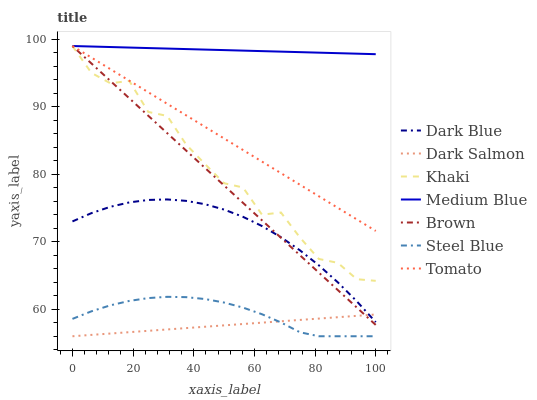Does Dark Salmon have the minimum area under the curve?
Answer yes or no. Yes. Does Medium Blue have the maximum area under the curve?
Answer yes or no. Yes. Does Brown have the minimum area under the curve?
Answer yes or no. No. Does Brown have the maximum area under the curve?
Answer yes or no. No. Is Dark Salmon the smoothest?
Answer yes or no. Yes. Is Khaki the roughest?
Answer yes or no. Yes. Is Brown the smoothest?
Answer yes or no. No. Is Brown the roughest?
Answer yes or no. No. Does Brown have the lowest value?
Answer yes or no. No. Does Medium Blue have the highest value?
Answer yes or no. Yes. Does Steel Blue have the highest value?
Answer yes or no. No. Is Dark Salmon less than Medium Blue?
Answer yes or no. Yes. Is Khaki greater than Steel Blue?
Answer yes or no. Yes. Does Dark Salmon intersect Steel Blue?
Answer yes or no. Yes. Is Dark Salmon less than Steel Blue?
Answer yes or no. No. Is Dark Salmon greater than Steel Blue?
Answer yes or no. No. Does Dark Salmon intersect Medium Blue?
Answer yes or no. No. 